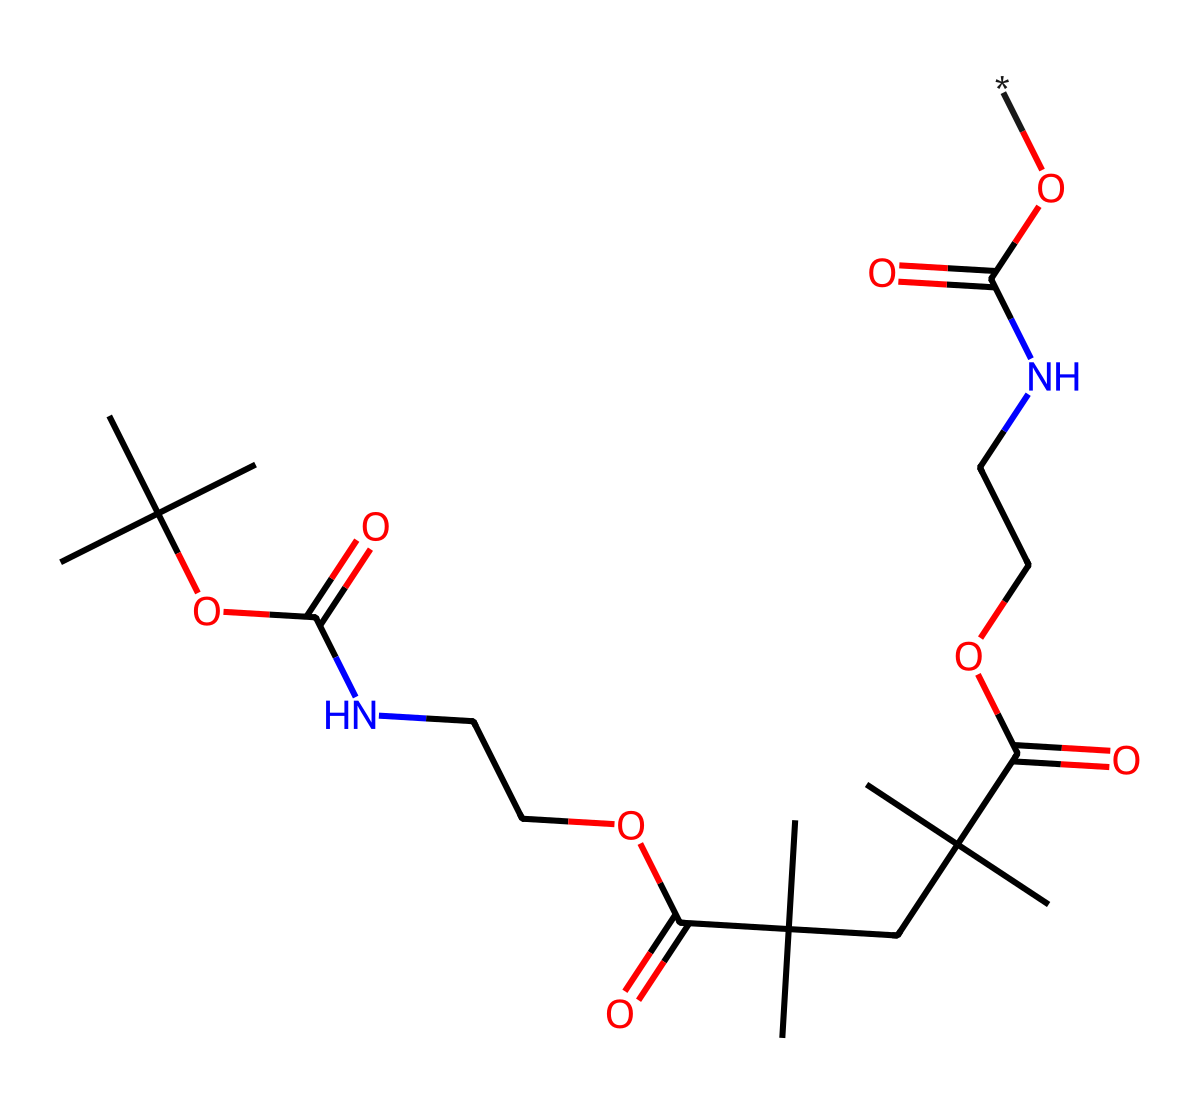What is the main functional group present in this polymer? The structure contains both ester and amide functional groups. The presence of carbonyl groups (C=O) attached to oxygen atoms suggests esters, while carbonyls attached to nitrogen indicate amides. Since spandex is a polyurethane, the most prominent functional group in the polymer overall is the urethane group which is featured due to the presence of both these groups.
Answer: urethane How many carbon atoms are in the polymer structure? To identify the number of carbon atoms, we count each 'C' in the SMILES notation. The presence of branching groups also contributes additional carbon atoms. Upon careful inspection, a total of 22 carbon atoms can be counted.
Answer: 22 What type of polymer is represented by this structure? The chemical structure contains repeating units that are characteristic of polyurethanes, identified by the recurrent urethane linkages formed through the reaction of diisocyanates and polyols. The specific arrangement and branching suggest it is a flexible fiber polymer.
Answer: polyurethane What type of linkage connects the repeating units in this polymer? Analyzing the structure shows a series of -NH-CO- linkages, which are indicative of a urethane linkage between the monomer units. This connection is crucial for imparting the elastic properties observed in compression garments made from spandex.
Answer: urethane How many oxygen atoms are present in the polymer structure? Similar to counting carbon atoms, we identify all instances of the letter 'O' in the SMILES representation. After thorough counting, we find there are 6 oxygen atoms present in the polymer structure.
Answer: 6 